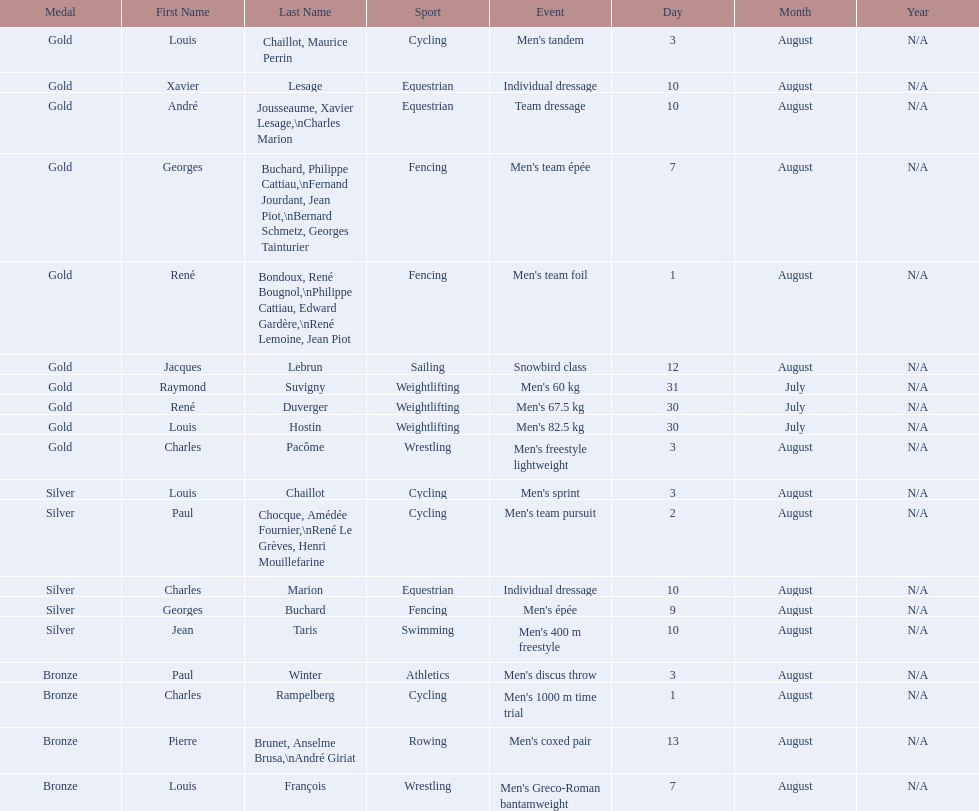Was there more gold medals won than silver? Yes. Would you be able to parse every entry in this table? {'header': ['Medal', 'First Name', 'Last Name', 'Sport', 'Event', 'Day', 'Month', 'Year'], 'rows': [['Gold', 'Louis', 'Chaillot, Maurice Perrin', 'Cycling', "Men's tandem", '3', 'August', 'N/A'], ['Gold', 'Xavier', 'Lesage', 'Equestrian', 'Individual dressage', '10', 'August', 'N/A'], ['Gold', 'André', 'Jousseaume, Xavier Lesage,\\nCharles Marion', 'Equestrian', 'Team dressage', '10', 'August', 'N/A'], ['Gold', 'Georges', 'Buchard, Philippe Cattiau,\\nFernand Jourdant, Jean Piot,\\nBernard Schmetz, Georges Tainturier', 'Fencing', "Men's team épée", '7', 'August', 'N/A'], ['Gold', 'René', 'Bondoux, René Bougnol,\\nPhilippe Cattiau, Edward Gardère,\\nRené Lemoine, Jean Piot', 'Fencing', "Men's team foil", '1', 'August', 'N/A'], ['Gold', 'Jacques', 'Lebrun', 'Sailing', 'Snowbird class', '12', 'August', 'N/A'], ['Gold', 'Raymond', 'Suvigny', 'Weightlifting', "Men's 60 kg", '31', 'July', 'N/A'], ['Gold', 'René', 'Duverger', 'Weightlifting', "Men's 67.5 kg", '30', 'July', 'N/A'], ['Gold', 'Louis', 'Hostin', 'Weightlifting', "Men's 82.5 kg", '30', 'July', 'N/A'], ['Gold', 'Charles', 'Pacôme', 'Wrestling', "Men's freestyle lightweight", '3', 'August', 'N/A'], ['Silver', 'Louis', 'Chaillot', 'Cycling', "Men's sprint", '3', 'August', 'N/A'], ['Silver', 'Paul', 'Chocque, Amédée Fournier,\\nRené Le Grèves, Henri Mouillefarine', 'Cycling', "Men's team pursuit", '2', 'August', 'N/A'], ['Silver', 'Charles', 'Marion', 'Equestrian', 'Individual dressage', '10', 'August', 'N/A'], ['Silver', 'Georges', 'Buchard', 'Fencing', "Men's épée", '9', 'August', 'N/A'], ['Silver', 'Jean', 'Taris', 'Swimming', "Men's 400 m freestyle", '10', 'August', 'N/A'], ['Bronze', 'Paul', 'Winter', 'Athletics', "Men's discus throw", '3', 'August', 'N/A'], ['Bronze', 'Charles', 'Rampelberg', 'Cycling', "Men's 1000 m time trial", '1', 'August', 'N/A'], ['Bronze', 'Pierre', 'Brunet, Anselme Brusa,\\nAndré Giriat', 'Rowing', "Men's coxed pair", '13', 'August', 'N/A'], ['Bronze', 'Louis', 'François', 'Wrestling', "Men's Greco-Roman bantamweight", '7', 'August', 'N/A']]} 